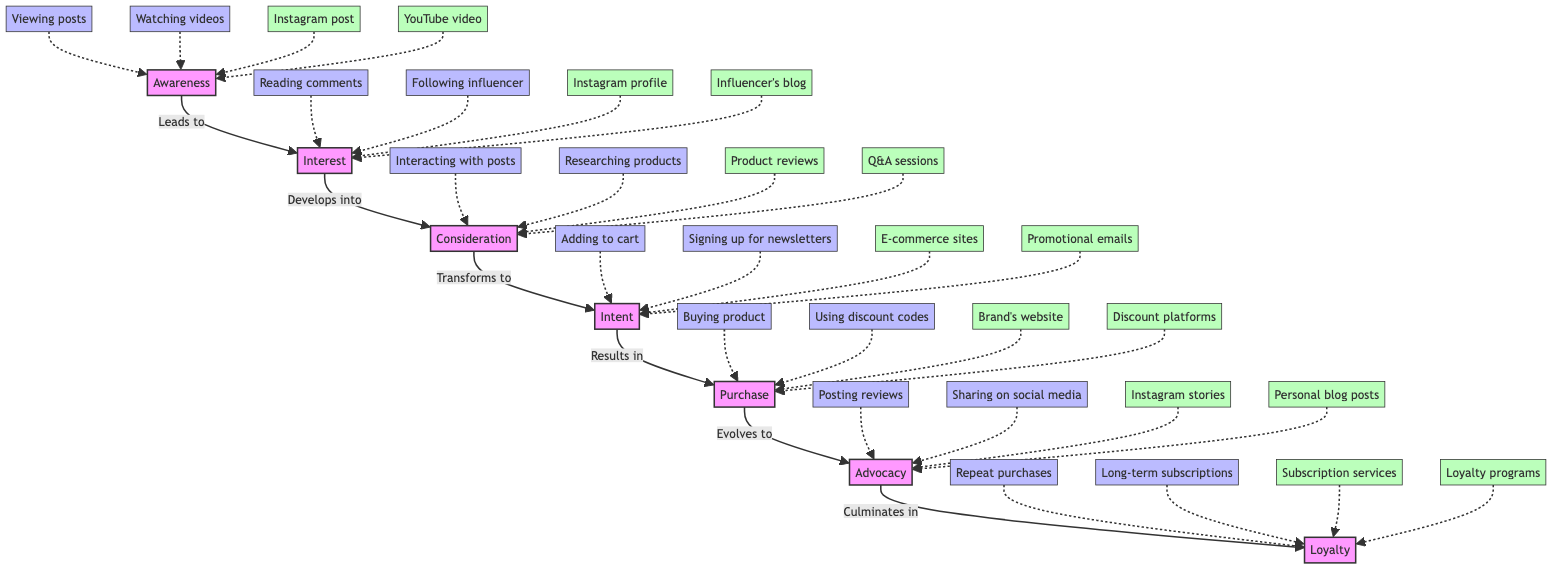What is the final stage of consumer engagement with influencer content? The diagram shows "Loyalty" at the top as the final stage in the flow of consumer engagement with influencer content, indicating the last point of progression in the consumer journey.
Answer: Loyalty How many stages are there in total? By counting all the distinct named stages present in the diagram, I identify seven stages: Awareness, Interest, Consideration, Intent, Purchase, Advocacy, and Loyalty.
Answer: 7 What leads from Intent to Purchase? The diagram indicates an arrow labeled "Results in" that connects the "Intent" stage to the "Purchase" stage, showing the progression that occurs when intent translates into action.
Answer: Results in Which stage can be reached by interacting with posts? The action of "Interacting with posts" is linked with the stage "Consideration" as indicated by the connection in the flow where this action leads to further evaluation and contemplation.
Answer: Consideration What type of actions are linked to the Advocacy stage? The actions associated with the "Advocacy" stage include "Posting reviews" and "Sharing on social media", which are specified as activities that consumers undertake when they have positive experiences.
Answer: Posting reviews, Sharing on social media What is the relationship between Awareness and Interest? The diagram indicates that Awareness leads to Interest, as there is an arrow that points upwards from "Awareness" to "Interest", meaning that this stage is a precursor to developing interest.
Answer: Leads to Which real-world entity is associated with the Purchase stage? The "Purchase" stage is associated with real-world entities like "Brand's website" and "Discount code platforms", providing concrete examples of environments where a purchase can occur.
Answer: Brand's website What signifies a consumer's clear intention in their journey? The action "Adding products to cart" acts as a clear indicator of consumer intent, indicating a strong step towards actual purchase aligned with the "Intent" stage in the diagram.
Answer: Adding products to cart What evolves from the Purchase stage? The "Purchase" stage evolves to "Advocacy" according to the diagram's flow, indicating how completing a purchase can lead consumers to promote their experiences and products to others.
Answer: Evolves to 